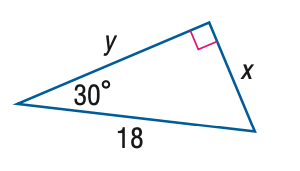Question: Find y.
Choices:
A. 9
B. 10.4
C. 12.7
D. 15.6
Answer with the letter. Answer: D Question: Find x.
Choices:
A. 6
B. 9
C. 10.4
D. 12.7
Answer with the letter. Answer: B 